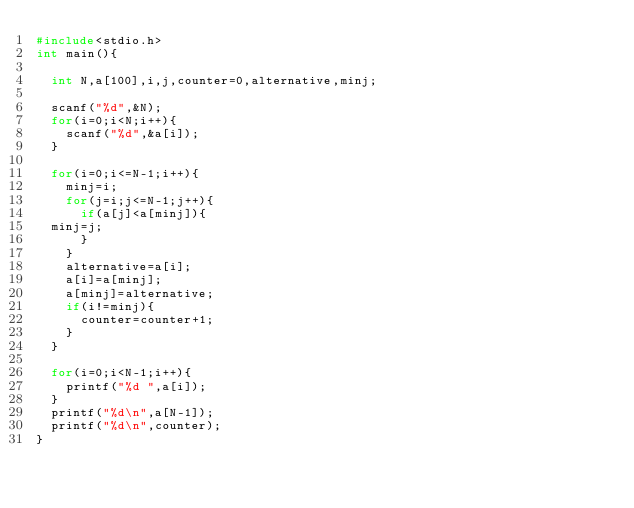<code> <loc_0><loc_0><loc_500><loc_500><_C_>#include<stdio.h>
int main(){
  
  int N,a[100],i,j,counter=0,alternative,minj;
  
  scanf("%d",&N);
  for(i=0;i<N;i++){
    scanf("%d",&a[i]);
  }
  
  for(i=0;i<=N-1;i++){
    minj=i;
    for(j=i;j<=N-1;j++){
      if(a[j]<a[minj]){
	minj=j;
      }
    }
    alternative=a[i];
    a[i]=a[minj];
    a[minj]=alternative;
    if(i!=minj){
      counter=counter+1;
    }
  }
  
  for(i=0;i<N-1;i++){
    printf("%d ",a[i]);
  }
  printf("%d\n",a[N-1]);
  printf("%d\n",counter);
}</code> 